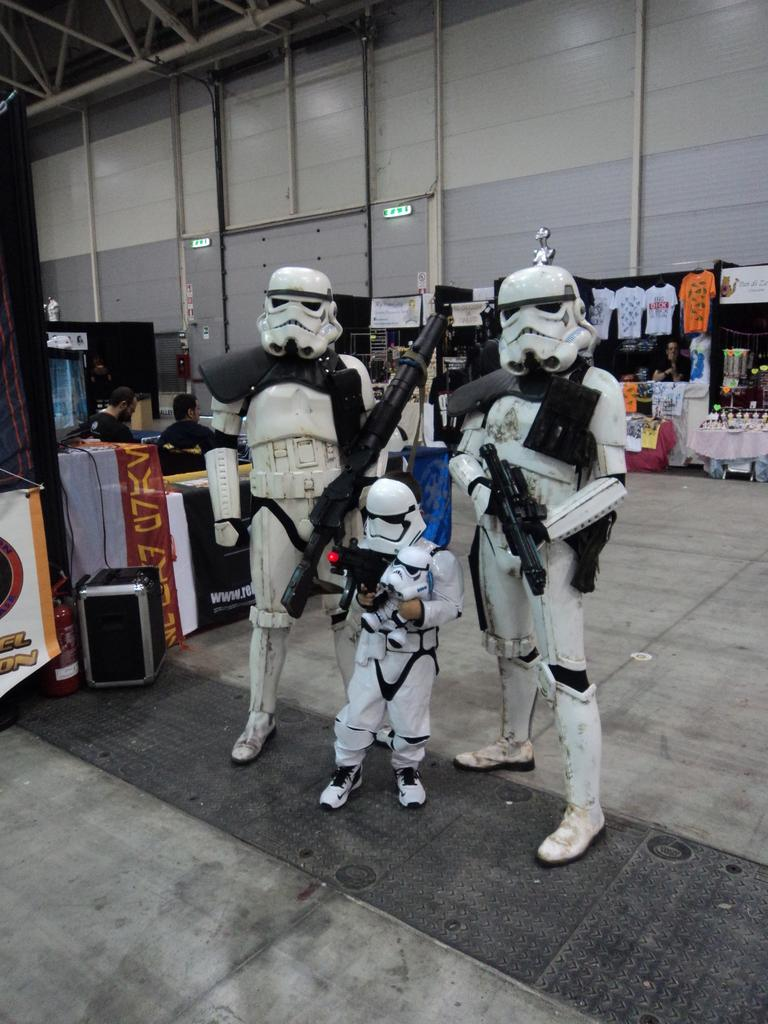What is the main subject in the center of the image? There are robots in the center of the image. What type of furniture can be seen in the image? There are tables in the image. What are the people in the image doing? People are sitting in the image. What kind of structures are present in the image? There are stalls in the image. What items can be found at the stalls? Clothes are present in the image. What can be seen in the background of the image? There is a wall and pipes visible in the background of the image. What type of stew is being served by the judge in the image? There is no judge or stew present in the image; it features robots, tables, people, stalls, clothes, a wall, and pipes. What scent can be detected from the image? The image does not provide any information about scents, as it is a visual representation. 